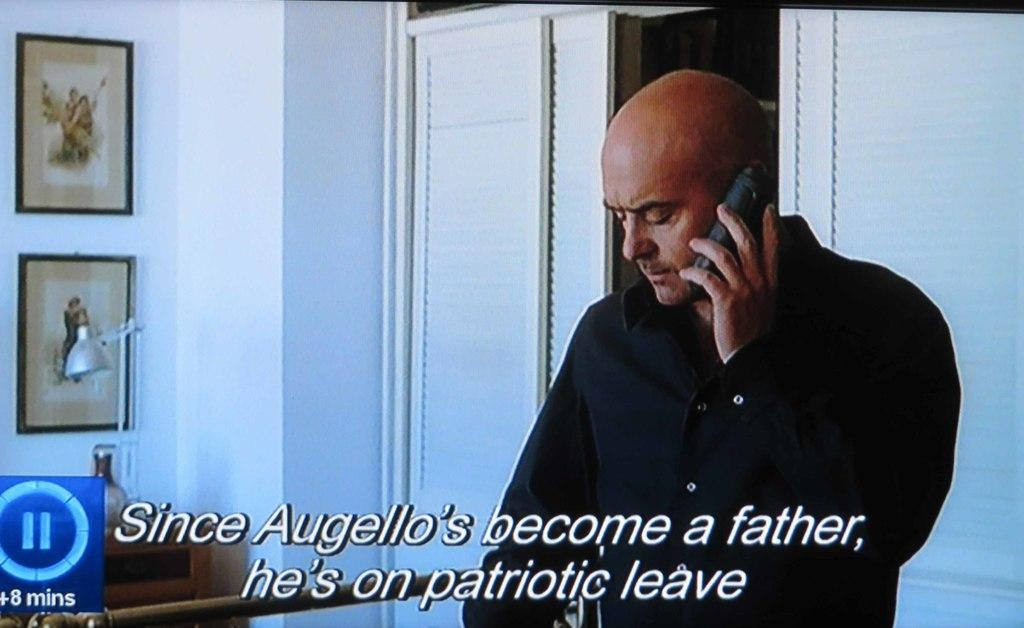What is the main subject of the image? There is a person in the image. What is the person wearing? The person is wearing a black dress. What is the person holding in the image? The person is holding a mobile. What can be seen on the wall in the background? There are frames attached to the wall in the background. What type of lighting is present in the background? There is a table light in the background. What color is the wall in the image? The wall is white in color. What type of planes can be seen flying in the image? There are no planes visible in the image; it features a person holding a mobile in front of a white wall with frames and a table light in the background. What kind of drug is the person taking in the image? There is no indication in the image that the person is taking any drug, and it is not appropriate to make assumptions about someone's actions based on a single image. 